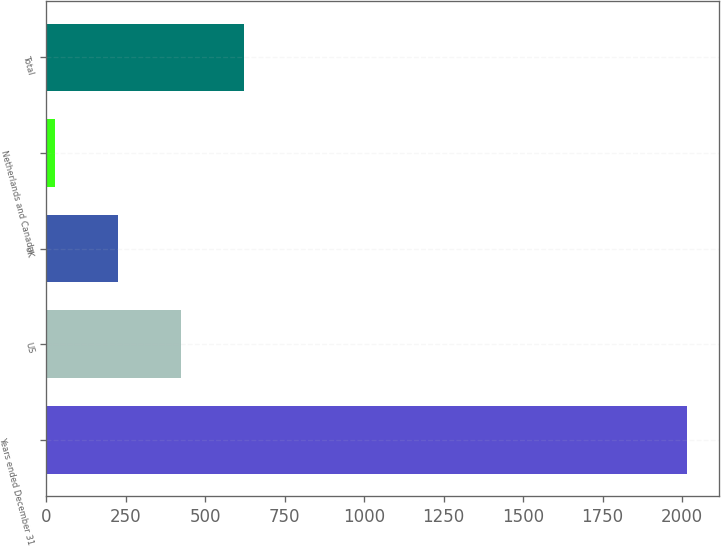Convert chart. <chart><loc_0><loc_0><loc_500><loc_500><bar_chart><fcel>Years ended December 31<fcel>US<fcel>UK<fcel>Netherlands and Canada<fcel>Total<nl><fcel>2016<fcel>424.8<fcel>225.9<fcel>27<fcel>623.7<nl></chart> 